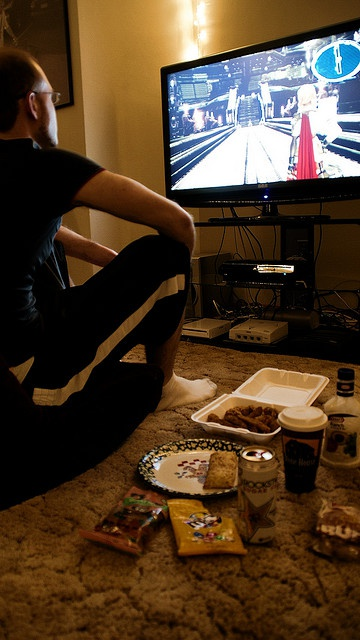Describe the objects in this image and their specific colors. I can see people in black, maroon, and brown tones, tv in black, white, darkgray, and gray tones, bottle in black, maroon, and olive tones, cup in black, maroon, olive, and tan tones, and bottle in black, maroon, and olive tones in this image. 